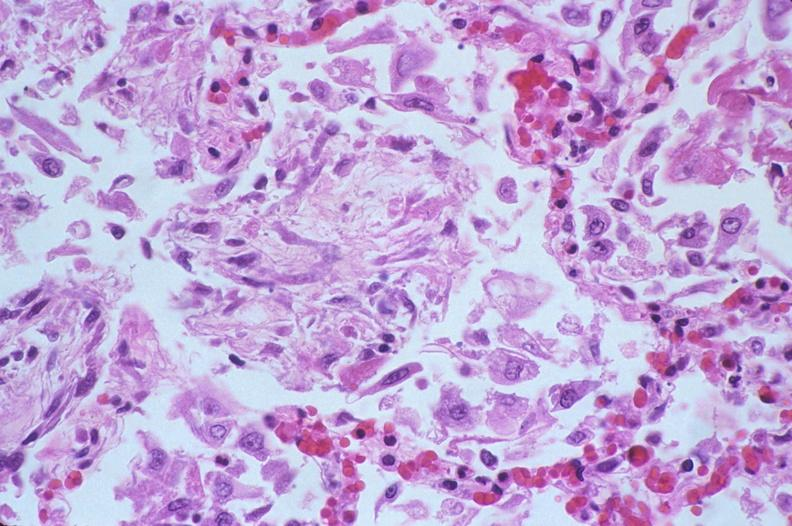what does this image show?
Answer the question using a single word or phrase. Lung 